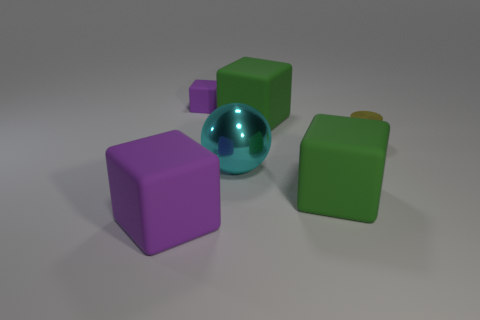What size is the other purple rubber thing that is the same shape as the big purple thing?
Your answer should be compact. Small. The cube that is the same color as the small rubber object is what size?
Make the answer very short. Large. The cyan sphere that is made of the same material as the tiny cylinder is what size?
Offer a very short reply. Large. There is a purple matte thing that is on the right side of the large rubber object that is on the left side of the small matte thing; how many purple rubber objects are to the left of it?
Your answer should be very brief. 1. Do the small block and the large rubber thing that is to the left of the big metallic sphere have the same color?
Provide a succinct answer. Yes. There is a purple object that is right of the purple matte object that is in front of the purple thing behind the tiny yellow object; what is its material?
Make the answer very short. Rubber. Is the shape of the big green matte thing behind the small cylinder the same as  the big cyan metal object?
Provide a succinct answer. No. There is a cylinder behind the big metal sphere; what material is it?
Offer a very short reply. Metal. What number of metal things are either purple blocks or small cubes?
Offer a terse response. 0. Are there any things of the same size as the yellow metal cylinder?
Ensure brevity in your answer.  Yes. 